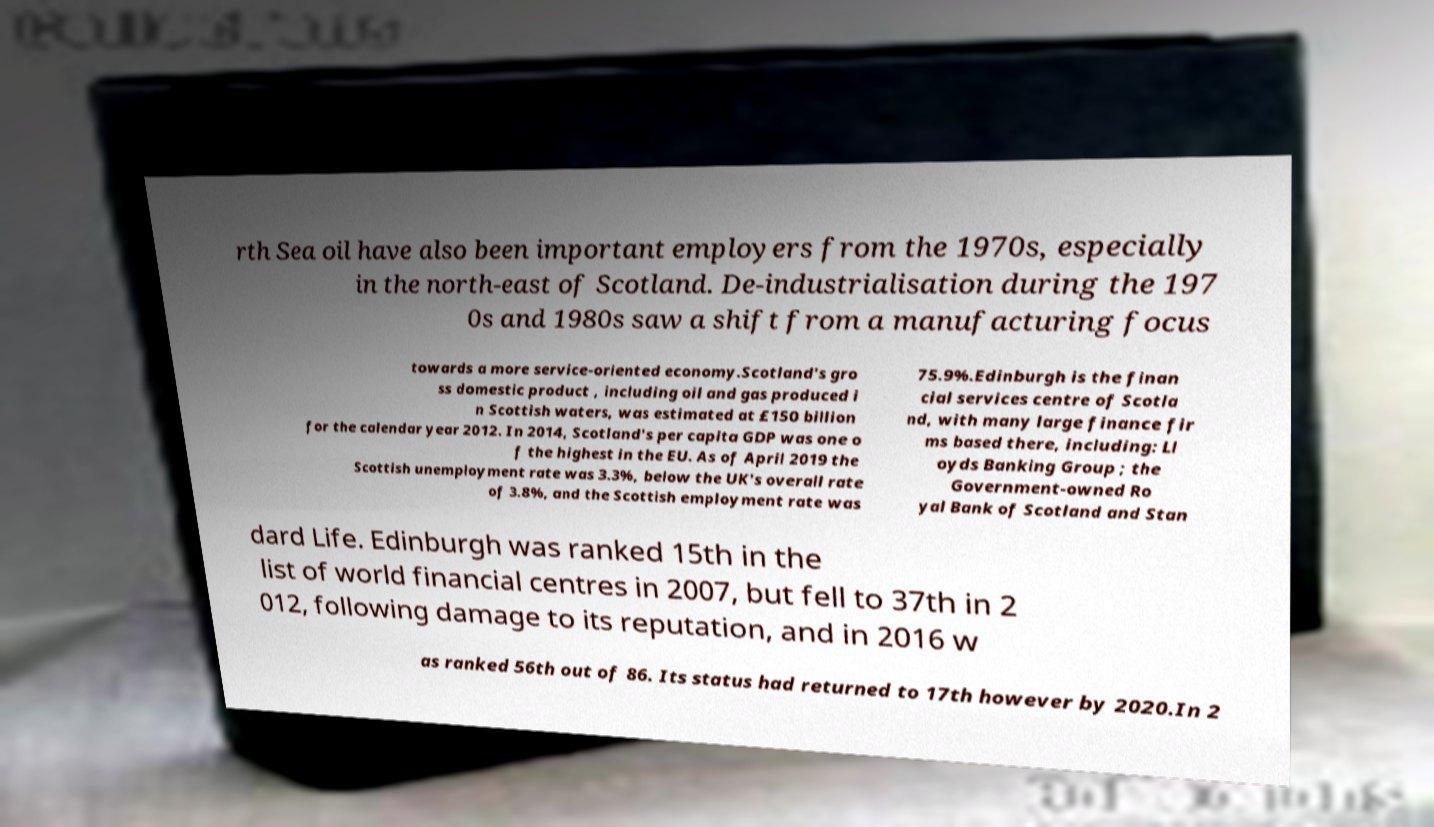I need the written content from this picture converted into text. Can you do that? rth Sea oil have also been important employers from the 1970s, especially in the north-east of Scotland. De-industrialisation during the 197 0s and 1980s saw a shift from a manufacturing focus towards a more service-oriented economy.Scotland's gro ss domestic product , including oil and gas produced i n Scottish waters, was estimated at £150 billion for the calendar year 2012. In 2014, Scotland's per capita GDP was one o f the highest in the EU. As of April 2019 the Scottish unemployment rate was 3.3%, below the UK's overall rate of 3.8%, and the Scottish employment rate was 75.9%.Edinburgh is the finan cial services centre of Scotla nd, with many large finance fir ms based there, including: Ll oyds Banking Group ; the Government-owned Ro yal Bank of Scotland and Stan dard Life. Edinburgh was ranked 15th in the list of world financial centres in 2007, but fell to 37th in 2 012, following damage to its reputation, and in 2016 w as ranked 56th out of 86. Its status had returned to 17th however by 2020.In 2 